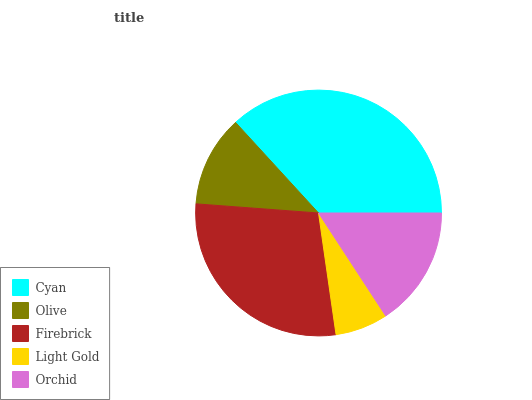Is Light Gold the minimum?
Answer yes or no. Yes. Is Cyan the maximum?
Answer yes or no. Yes. Is Olive the minimum?
Answer yes or no. No. Is Olive the maximum?
Answer yes or no. No. Is Cyan greater than Olive?
Answer yes or no. Yes. Is Olive less than Cyan?
Answer yes or no. Yes. Is Olive greater than Cyan?
Answer yes or no. No. Is Cyan less than Olive?
Answer yes or no. No. Is Orchid the high median?
Answer yes or no. Yes. Is Orchid the low median?
Answer yes or no. Yes. Is Cyan the high median?
Answer yes or no. No. Is Light Gold the low median?
Answer yes or no. No. 